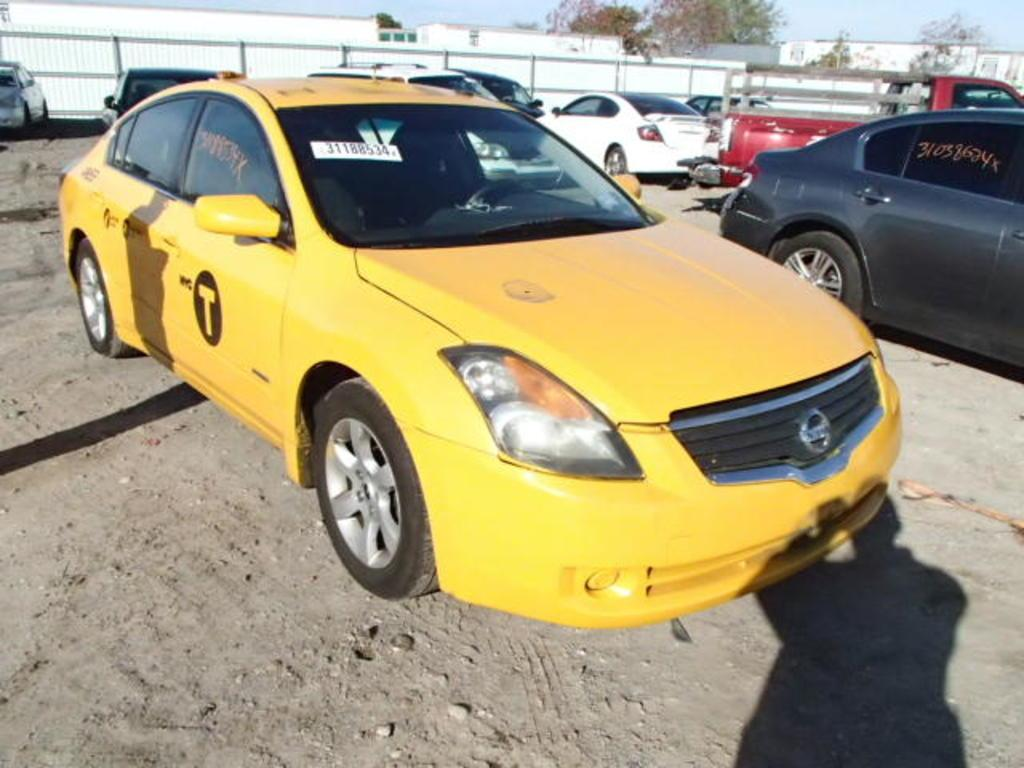<image>
Offer a succinct explanation of the picture presented. A yellow car has a letter T on the front passenger side door. 